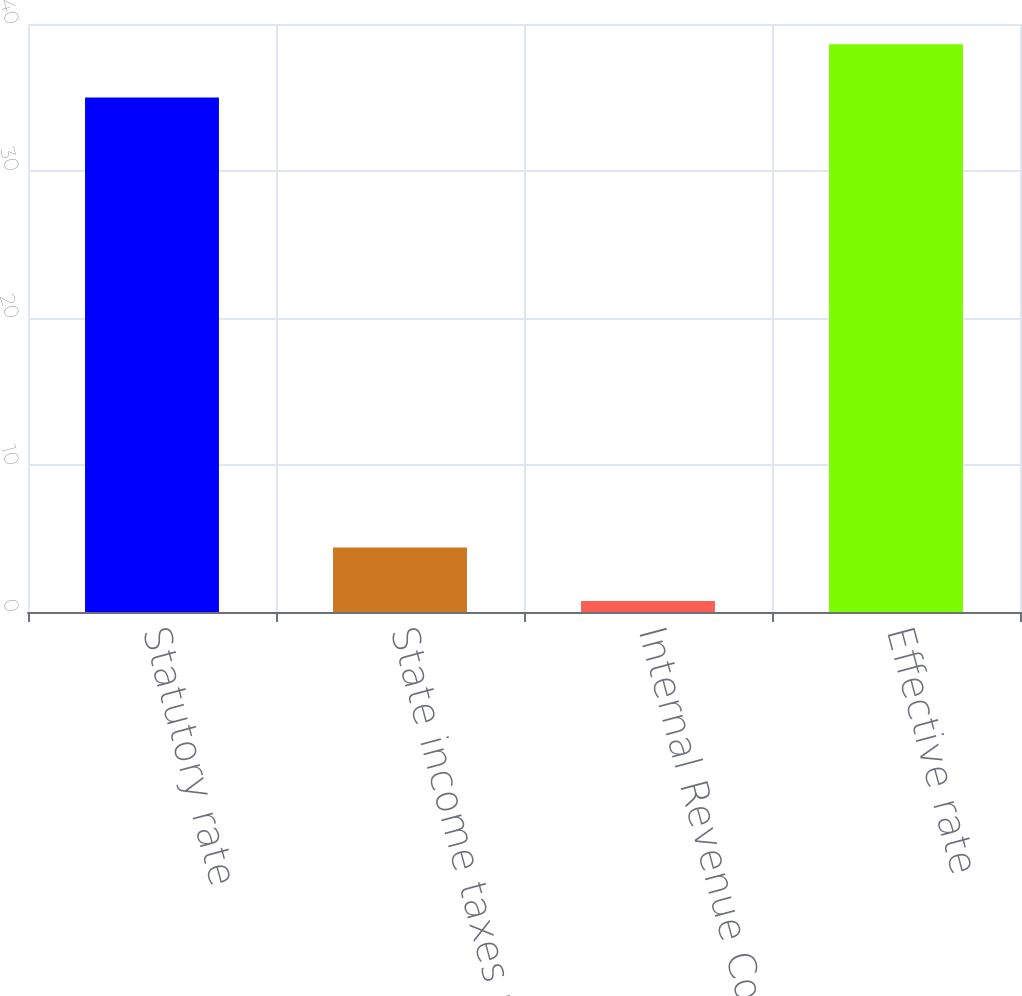<chart> <loc_0><loc_0><loc_500><loc_500><bar_chart><fcel>Statutory rate<fcel>State income taxes net of<fcel>Internal Revenue Code Section<fcel>Effective rate<nl><fcel>35<fcel>4.38<fcel>0.75<fcel>38.62<nl></chart> 